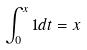<formula> <loc_0><loc_0><loc_500><loc_500>\int _ { 0 } ^ { x } 1 d t = x</formula> 